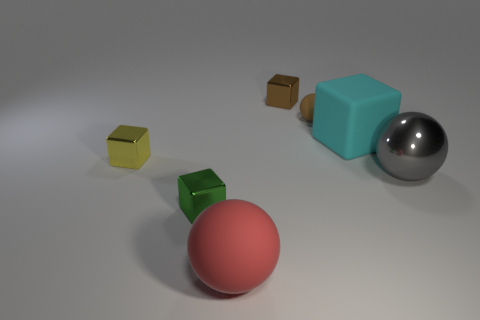Imagine these objects were part of a physics experiment, what sort of experiment could it be? These objects might be used in an experiment to demonstrate various physical principles. For example, a setup like this could illustrate differences in material density, surface friction, or reflectivity. The metal ball could represent a perfect sphere for discussing topics like specular reflection, while the textured surfaces of the cubes could relate to friction experiments. 